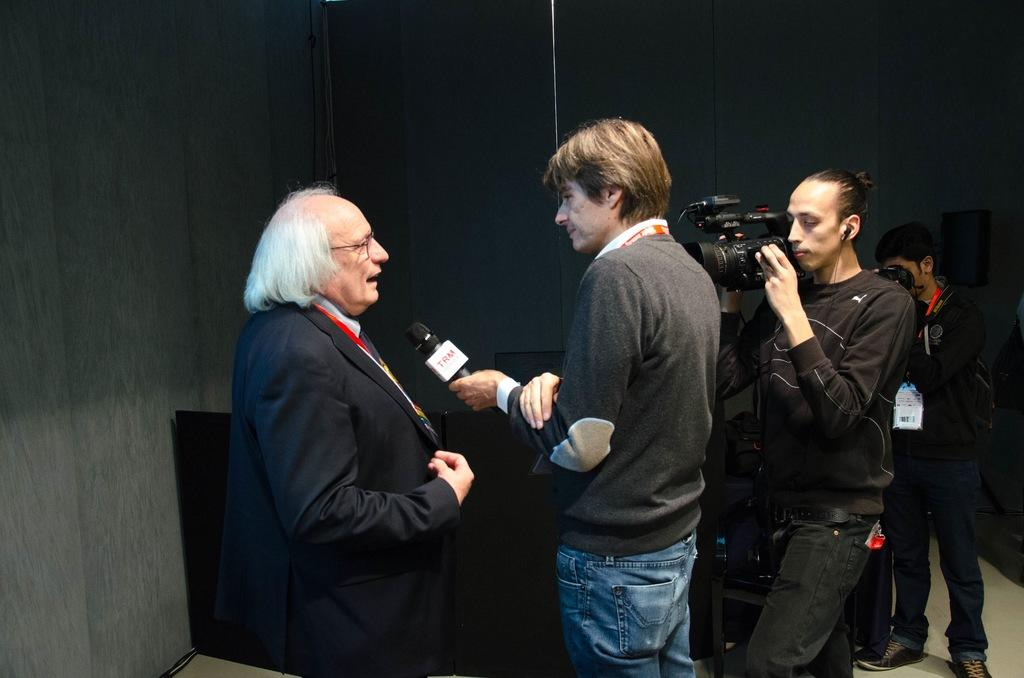How many people are present in the image? There are four people in the image. What is the attire of one of the individuals? One person is wearing a black suit. What is the person in the black suit doing? The person in the black suit is talking. What is the attire of another individual? One person is wearing blue jeans. What is the person in blue jeans holding? The person in blue jeans is holding a microphone. What are two people doing in the image? Two people are holding cameras. What type of pet can be seen in the image? There is no pet visible in the image. What is the weight of the person holding the microphone? The weight of the person holding the microphone cannot be determined from the image. 